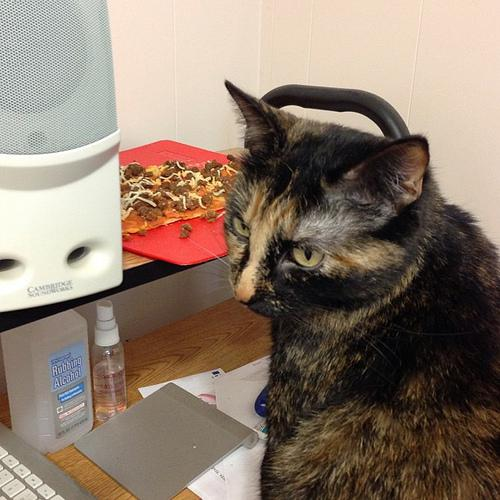Question: where is the cat?
Choices:
A. On the couch.
B. On the counter.
C. Next to pizza.
D. In the sink.
Answer with the letter. Answer: C Question: how does the cat look?
Choices:
A. Curious.
B. Frightened.
C. Mad.
D. Loving.
Answer with the letter. Answer: A 